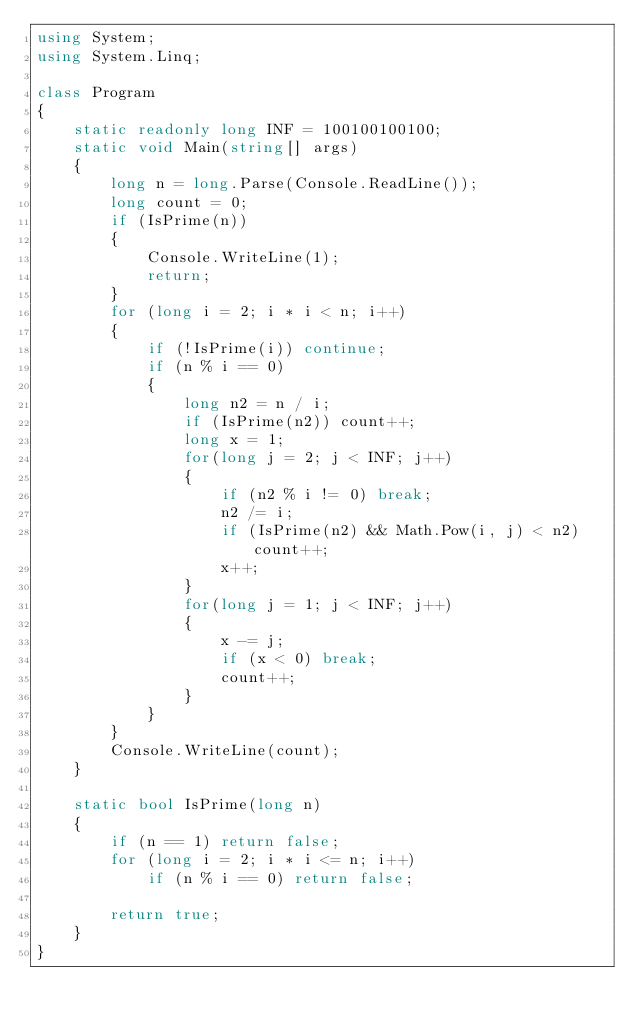Convert code to text. <code><loc_0><loc_0><loc_500><loc_500><_C#_>using System;
using System.Linq;

class Program
{
    static readonly long INF = 100100100100;
    static void Main(string[] args)
    {
        long n = long.Parse(Console.ReadLine());
        long count = 0;
        if (IsPrime(n))
        {
            Console.WriteLine(1);
            return;
        }
        for (long i = 2; i * i < n; i++)
        {
            if (!IsPrime(i)) continue;
            if (n % i == 0)
            {
                long n2 = n / i;
                if (IsPrime(n2)) count++;
                long x = 1;
                for(long j = 2; j < INF; j++)
                {
                    if (n2 % i != 0) break;
                    n2 /= i;
                    if (IsPrime(n2) && Math.Pow(i, j) < n2) count++;
                    x++;
                }
                for(long j = 1; j < INF; j++)
                {
                    x -= j;
                    if (x < 0) break;
                    count++;
                }
            }
        }
        Console.WriteLine(count);
    }

    static bool IsPrime(long n)
    {
        if (n == 1) return false;
        for (long i = 2; i * i <= n; i++)
            if (n % i == 0) return false;

        return true;
    }
}
</code> 